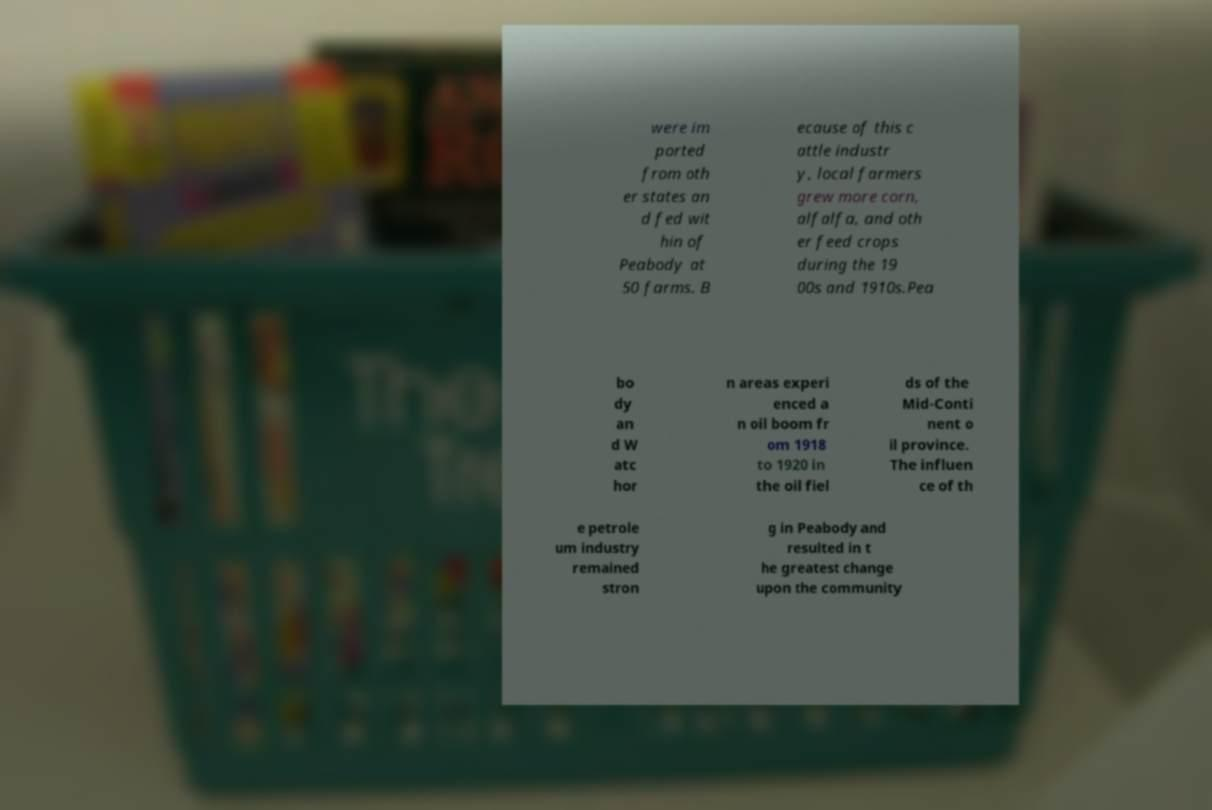Can you read and provide the text displayed in the image?This photo seems to have some interesting text. Can you extract and type it out for me? were im ported from oth er states an d fed wit hin of Peabody at 50 farms. B ecause of this c attle industr y, local farmers grew more corn, alfalfa, and oth er feed crops during the 19 00s and 1910s.Pea bo dy an d W atc hor n areas experi enced a n oil boom fr om 1918 to 1920 in the oil fiel ds of the Mid-Conti nent o il province. The influen ce of th e petrole um industry remained stron g in Peabody and resulted in t he greatest change upon the community 